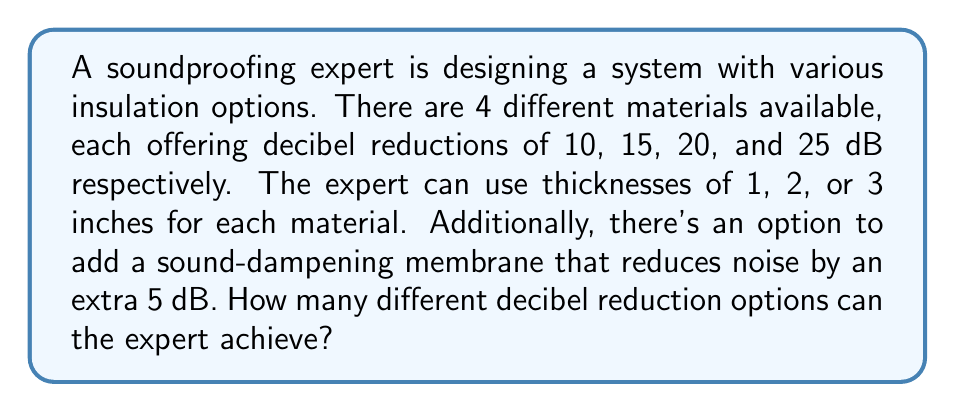Show me your answer to this math problem. Let's approach this step-by-step:

1) First, let's consider the options without the membrane:

   - Each material can be used in 3 thicknesses (1, 2, or 3 inches)
   - There are 4 materials

   So, we have $4 \times 3 = 12$ basic combinations.

2) Now, let's calculate the possible decibel reductions:

   - Material 1: 10 dB, 20 dB, 30 dB (for 1, 2, and 3 inches respectively)
   - Material 2: 15 dB, 30 dB, 45 dB
   - Material 3: 20 dB, 40 dB, 60 dB
   - Material 4: 25 dB, 50 dB, 75 dB

3) The unique decibel reductions are:
   10, 15, 20, 25, 30, 40, 45, 50, 60, 75

   So, without the membrane, there are 10 unique decibel reduction options.

4) Now, let's consider the membrane. It adds 5 dB to each option:
   15, 20, 25, 30, 35, 45, 50, 55, 65, 80

5) Some of these new options (20, 25, 30, 45, 50) overlap with the original set, but 15, 35, 55, 65, and 80 are new.

6) Therefore, the total number of unique decibel reduction options is:
   10 (original) + 5 (new from membrane) = 15

Thus, the expert can achieve 15 different decibel reduction options.
Answer: 15 different decibel reduction options 